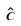Convert formula to latex. <formula><loc_0><loc_0><loc_500><loc_500>\hat { c }</formula> 